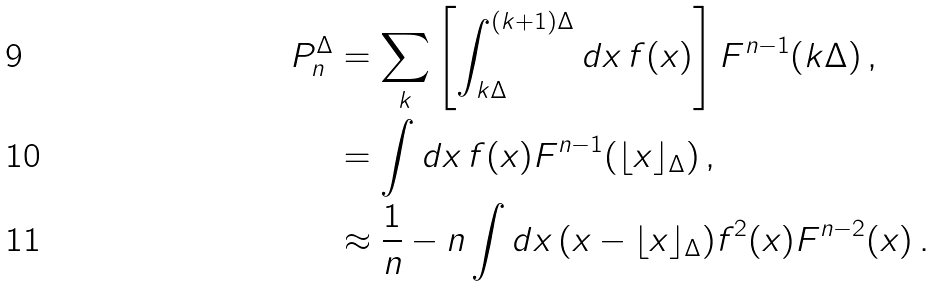<formula> <loc_0><loc_0><loc_500><loc_500>P _ { n } ^ { \Delta } & = \sum _ { k } \left [ \int _ { k \Delta } ^ { ( k + 1 ) \Delta } d x \, f ( x ) \right ] F ^ { n - 1 } ( k \Delta ) \, , \\ & = \int d x \, f ( x ) F ^ { n - 1 } ( \lfloor x \rfloor _ { \Delta } ) \, , \\ & \approx \frac { 1 } { n } - n \int d x \, ( x - \lfloor x \rfloor _ { \Delta } ) f ^ { 2 } ( x ) F ^ { n - 2 } ( x ) \, .</formula> 